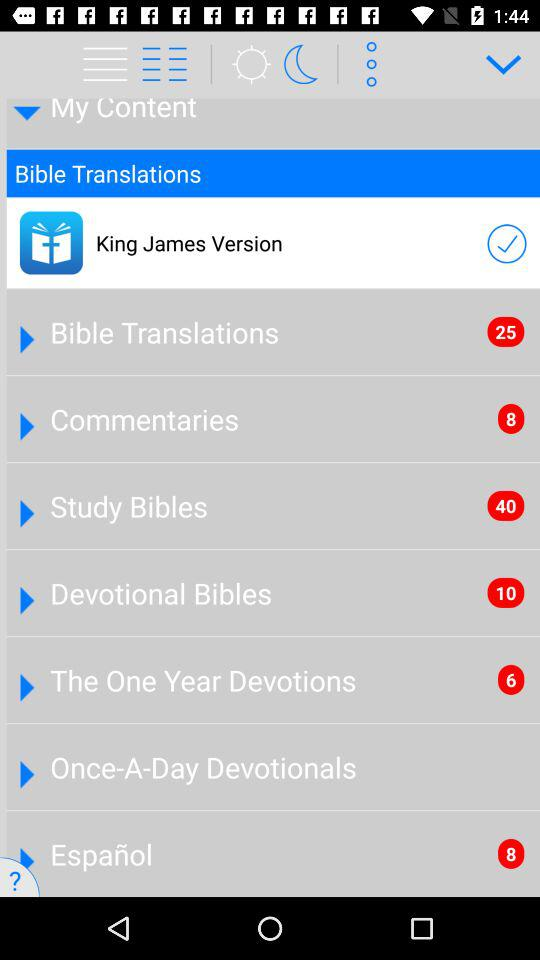How many more items are in the Bible Translations section than in the Commentaries section?
Answer the question using a single word or phrase. 17 